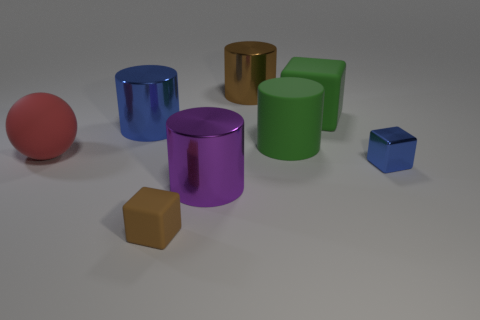Subtract all tiny cubes. How many cubes are left? 1 Subtract 1 blocks. How many blocks are left? 2 Subtract all brown cylinders. How many cylinders are left? 3 Subtract all gray cylinders. Subtract all purple spheres. How many cylinders are left? 4 Add 1 tiny brown objects. How many objects exist? 9 Subtract all balls. How many objects are left? 7 Add 3 green matte cylinders. How many green matte cylinders are left? 4 Add 2 tiny matte cylinders. How many tiny matte cylinders exist? 2 Subtract 1 green cubes. How many objects are left? 7 Subtract all brown rubber things. Subtract all spheres. How many objects are left? 6 